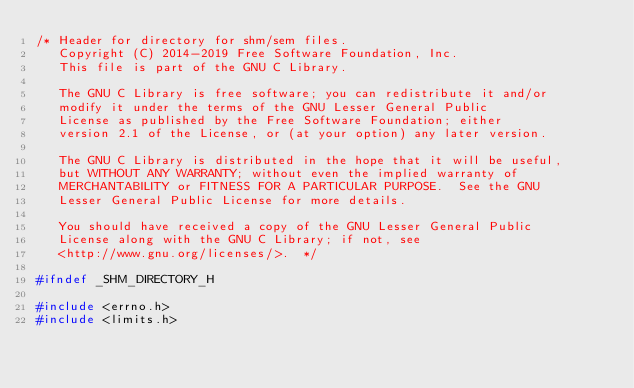<code> <loc_0><loc_0><loc_500><loc_500><_C_>/* Header for directory for shm/sem files.
   Copyright (C) 2014-2019 Free Software Foundation, Inc.
   This file is part of the GNU C Library.

   The GNU C Library is free software; you can redistribute it and/or
   modify it under the terms of the GNU Lesser General Public
   License as published by the Free Software Foundation; either
   version 2.1 of the License, or (at your option) any later version.

   The GNU C Library is distributed in the hope that it will be useful,
   but WITHOUT ANY WARRANTY; without even the implied warranty of
   MERCHANTABILITY or FITNESS FOR A PARTICULAR PURPOSE.  See the GNU
   Lesser General Public License for more details.

   You should have received a copy of the GNU Lesser General Public
   License along with the GNU C Library; if not, see
   <http://www.gnu.org/licenses/>.  */

#ifndef _SHM_DIRECTORY_H

#include <errno.h>
#include <limits.h></code> 